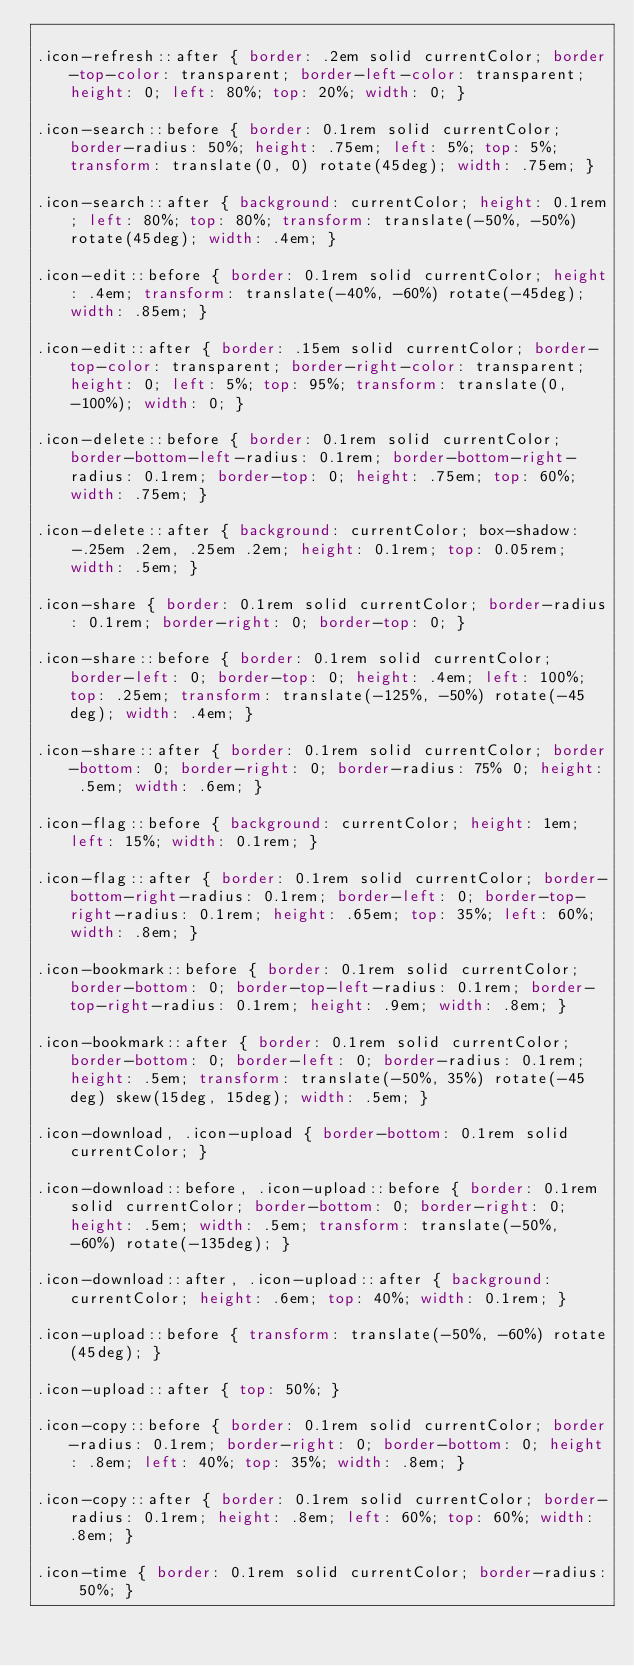<code> <loc_0><loc_0><loc_500><loc_500><_CSS_>
.icon-refresh::after { border: .2em solid currentColor; border-top-color: transparent; border-left-color: transparent; height: 0; left: 80%; top: 20%; width: 0; }

.icon-search::before { border: 0.1rem solid currentColor; border-radius: 50%; height: .75em; left: 5%; top: 5%; transform: translate(0, 0) rotate(45deg); width: .75em; }

.icon-search::after { background: currentColor; height: 0.1rem; left: 80%; top: 80%; transform: translate(-50%, -50%) rotate(45deg); width: .4em; }

.icon-edit::before { border: 0.1rem solid currentColor; height: .4em; transform: translate(-40%, -60%) rotate(-45deg); width: .85em; }

.icon-edit::after { border: .15em solid currentColor; border-top-color: transparent; border-right-color: transparent; height: 0; left: 5%; top: 95%; transform: translate(0, -100%); width: 0; }

.icon-delete::before { border: 0.1rem solid currentColor; border-bottom-left-radius: 0.1rem; border-bottom-right-radius: 0.1rem; border-top: 0; height: .75em; top: 60%; width: .75em; }

.icon-delete::after { background: currentColor; box-shadow: -.25em .2em, .25em .2em; height: 0.1rem; top: 0.05rem; width: .5em; }

.icon-share { border: 0.1rem solid currentColor; border-radius: 0.1rem; border-right: 0; border-top: 0; }

.icon-share::before { border: 0.1rem solid currentColor; border-left: 0; border-top: 0; height: .4em; left: 100%; top: .25em; transform: translate(-125%, -50%) rotate(-45deg); width: .4em; }

.icon-share::after { border: 0.1rem solid currentColor; border-bottom: 0; border-right: 0; border-radius: 75% 0; height: .5em; width: .6em; }

.icon-flag::before { background: currentColor; height: 1em; left: 15%; width: 0.1rem; }

.icon-flag::after { border: 0.1rem solid currentColor; border-bottom-right-radius: 0.1rem; border-left: 0; border-top-right-radius: 0.1rem; height: .65em; top: 35%; left: 60%; width: .8em; }

.icon-bookmark::before { border: 0.1rem solid currentColor; border-bottom: 0; border-top-left-radius: 0.1rem; border-top-right-radius: 0.1rem; height: .9em; width: .8em; }

.icon-bookmark::after { border: 0.1rem solid currentColor; border-bottom: 0; border-left: 0; border-radius: 0.1rem; height: .5em; transform: translate(-50%, 35%) rotate(-45deg) skew(15deg, 15deg); width: .5em; }

.icon-download, .icon-upload { border-bottom: 0.1rem solid currentColor; }

.icon-download::before, .icon-upload::before { border: 0.1rem solid currentColor; border-bottom: 0; border-right: 0; height: .5em; width: .5em; transform: translate(-50%, -60%) rotate(-135deg); }

.icon-download::after, .icon-upload::after { background: currentColor; height: .6em; top: 40%; width: 0.1rem; }

.icon-upload::before { transform: translate(-50%, -60%) rotate(45deg); }

.icon-upload::after { top: 50%; }

.icon-copy::before { border: 0.1rem solid currentColor; border-radius: 0.1rem; border-right: 0; border-bottom: 0; height: .8em; left: 40%; top: 35%; width: .8em; }

.icon-copy::after { border: 0.1rem solid currentColor; border-radius: 0.1rem; height: .8em; left: 60%; top: 60%; width: .8em; }

.icon-time { border: 0.1rem solid currentColor; border-radius: 50%; }
</code> 